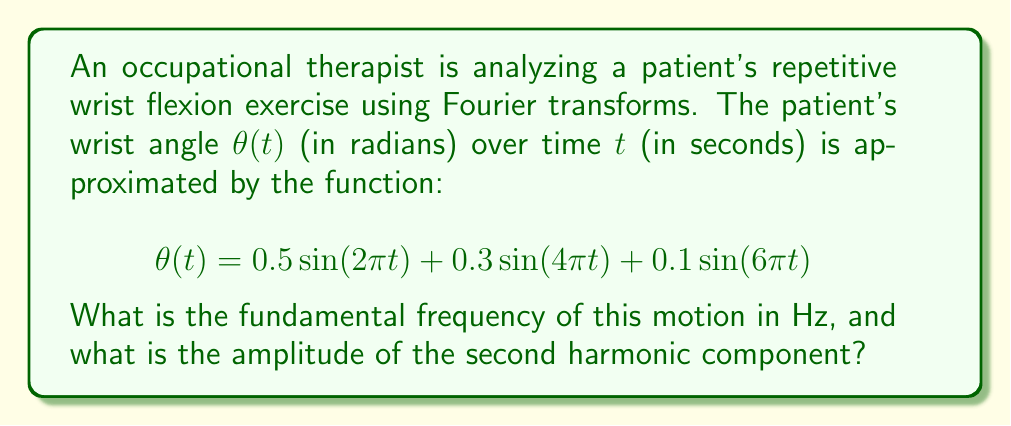Help me with this question. To solve this problem, we'll follow these steps:

1. Identify the fundamental frequency:
   The fundamental frequency is the lowest frequency component in the Fourier series. In this case, it's the frequency of the first sine term.

   $$f_1 = \frac{1}{T_1} = \frac{2\pi}{2\pi} = 1 \text{ Hz}$$

2. Identify the second harmonic:
   The second harmonic is the term with twice the fundamental frequency, which is the second term in our function.

   $$0.3\sin(4\pi t)$$

3. Determine the amplitude of the second harmonic:
   The amplitude is the coefficient in front of the sine function for this term.

   Amplitude of second harmonic = 0.3

Thus, the fundamental frequency is 1 Hz, and the amplitude of the second harmonic is 0.3.
Answer: 1 Hz, 0.3 